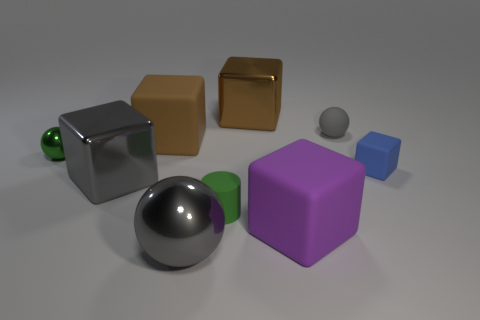Subtract 2 blocks. How many blocks are left? 3 Subtract all green blocks. Subtract all yellow spheres. How many blocks are left? 5 Add 1 big brown matte blocks. How many objects exist? 10 Subtract all cylinders. How many objects are left? 8 Subtract 0 red cubes. How many objects are left? 9 Subtract all small gray rubber spheres. Subtract all gray objects. How many objects are left? 5 Add 9 big metal balls. How many big metal balls are left? 10 Add 3 brown metallic things. How many brown metallic things exist? 4 